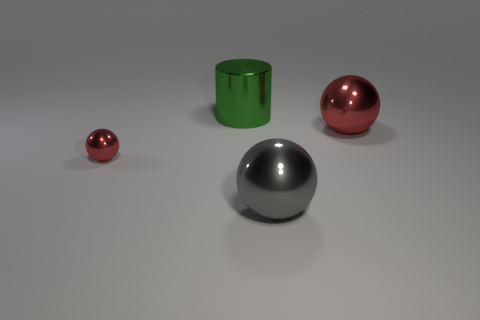Subtract all tiny red metal balls. How many balls are left? 2 Add 3 blue objects. How many objects exist? 7 Subtract all spheres. How many objects are left? 1 Add 2 tiny objects. How many tiny objects are left? 3 Add 4 large green cylinders. How many large green cylinders exist? 5 Subtract 0 blue cubes. How many objects are left? 4 Subtract all blocks. Subtract all big gray spheres. How many objects are left? 3 